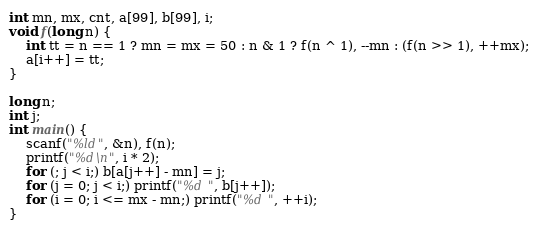<code> <loc_0><loc_0><loc_500><loc_500><_C_>int mn, mx, cnt, a[99], b[99], i;
void f(long n) {
	int tt = n == 1 ? mn = mx = 50 : n & 1 ? f(n ^ 1), --mn : (f(n >> 1), ++mx);
	a[i++] = tt;
}

long n;
int j;
int main() {
	scanf("%ld", &n), f(n);
	printf("%d\n", i * 2);
	for (; j < i;) b[a[j++] - mn] = j;
	for (j = 0; j < i;) printf("%d ", b[j++]);
	for (i = 0; i <= mx - mn;) printf("%d ", ++i);
}</code> 